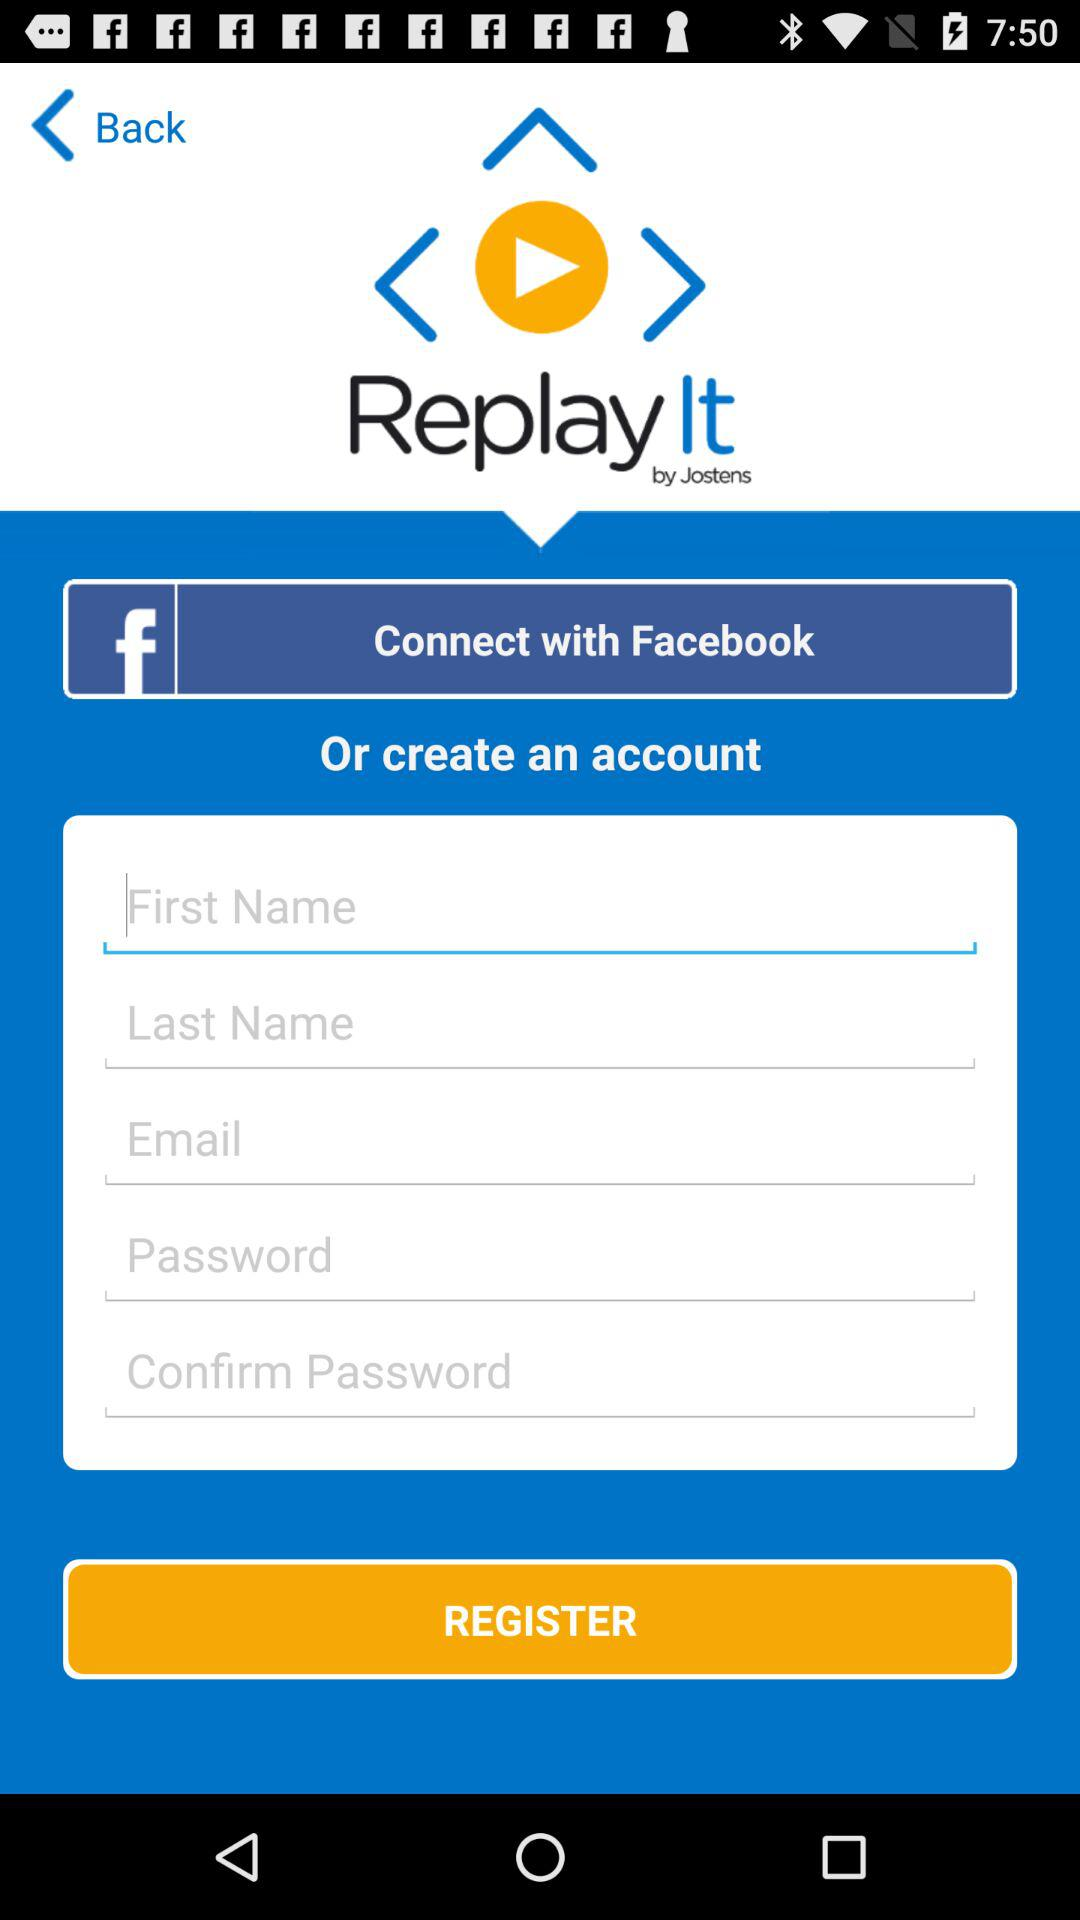How many text inputs are there for creating an account?
Answer the question using a single word or phrase. 5 